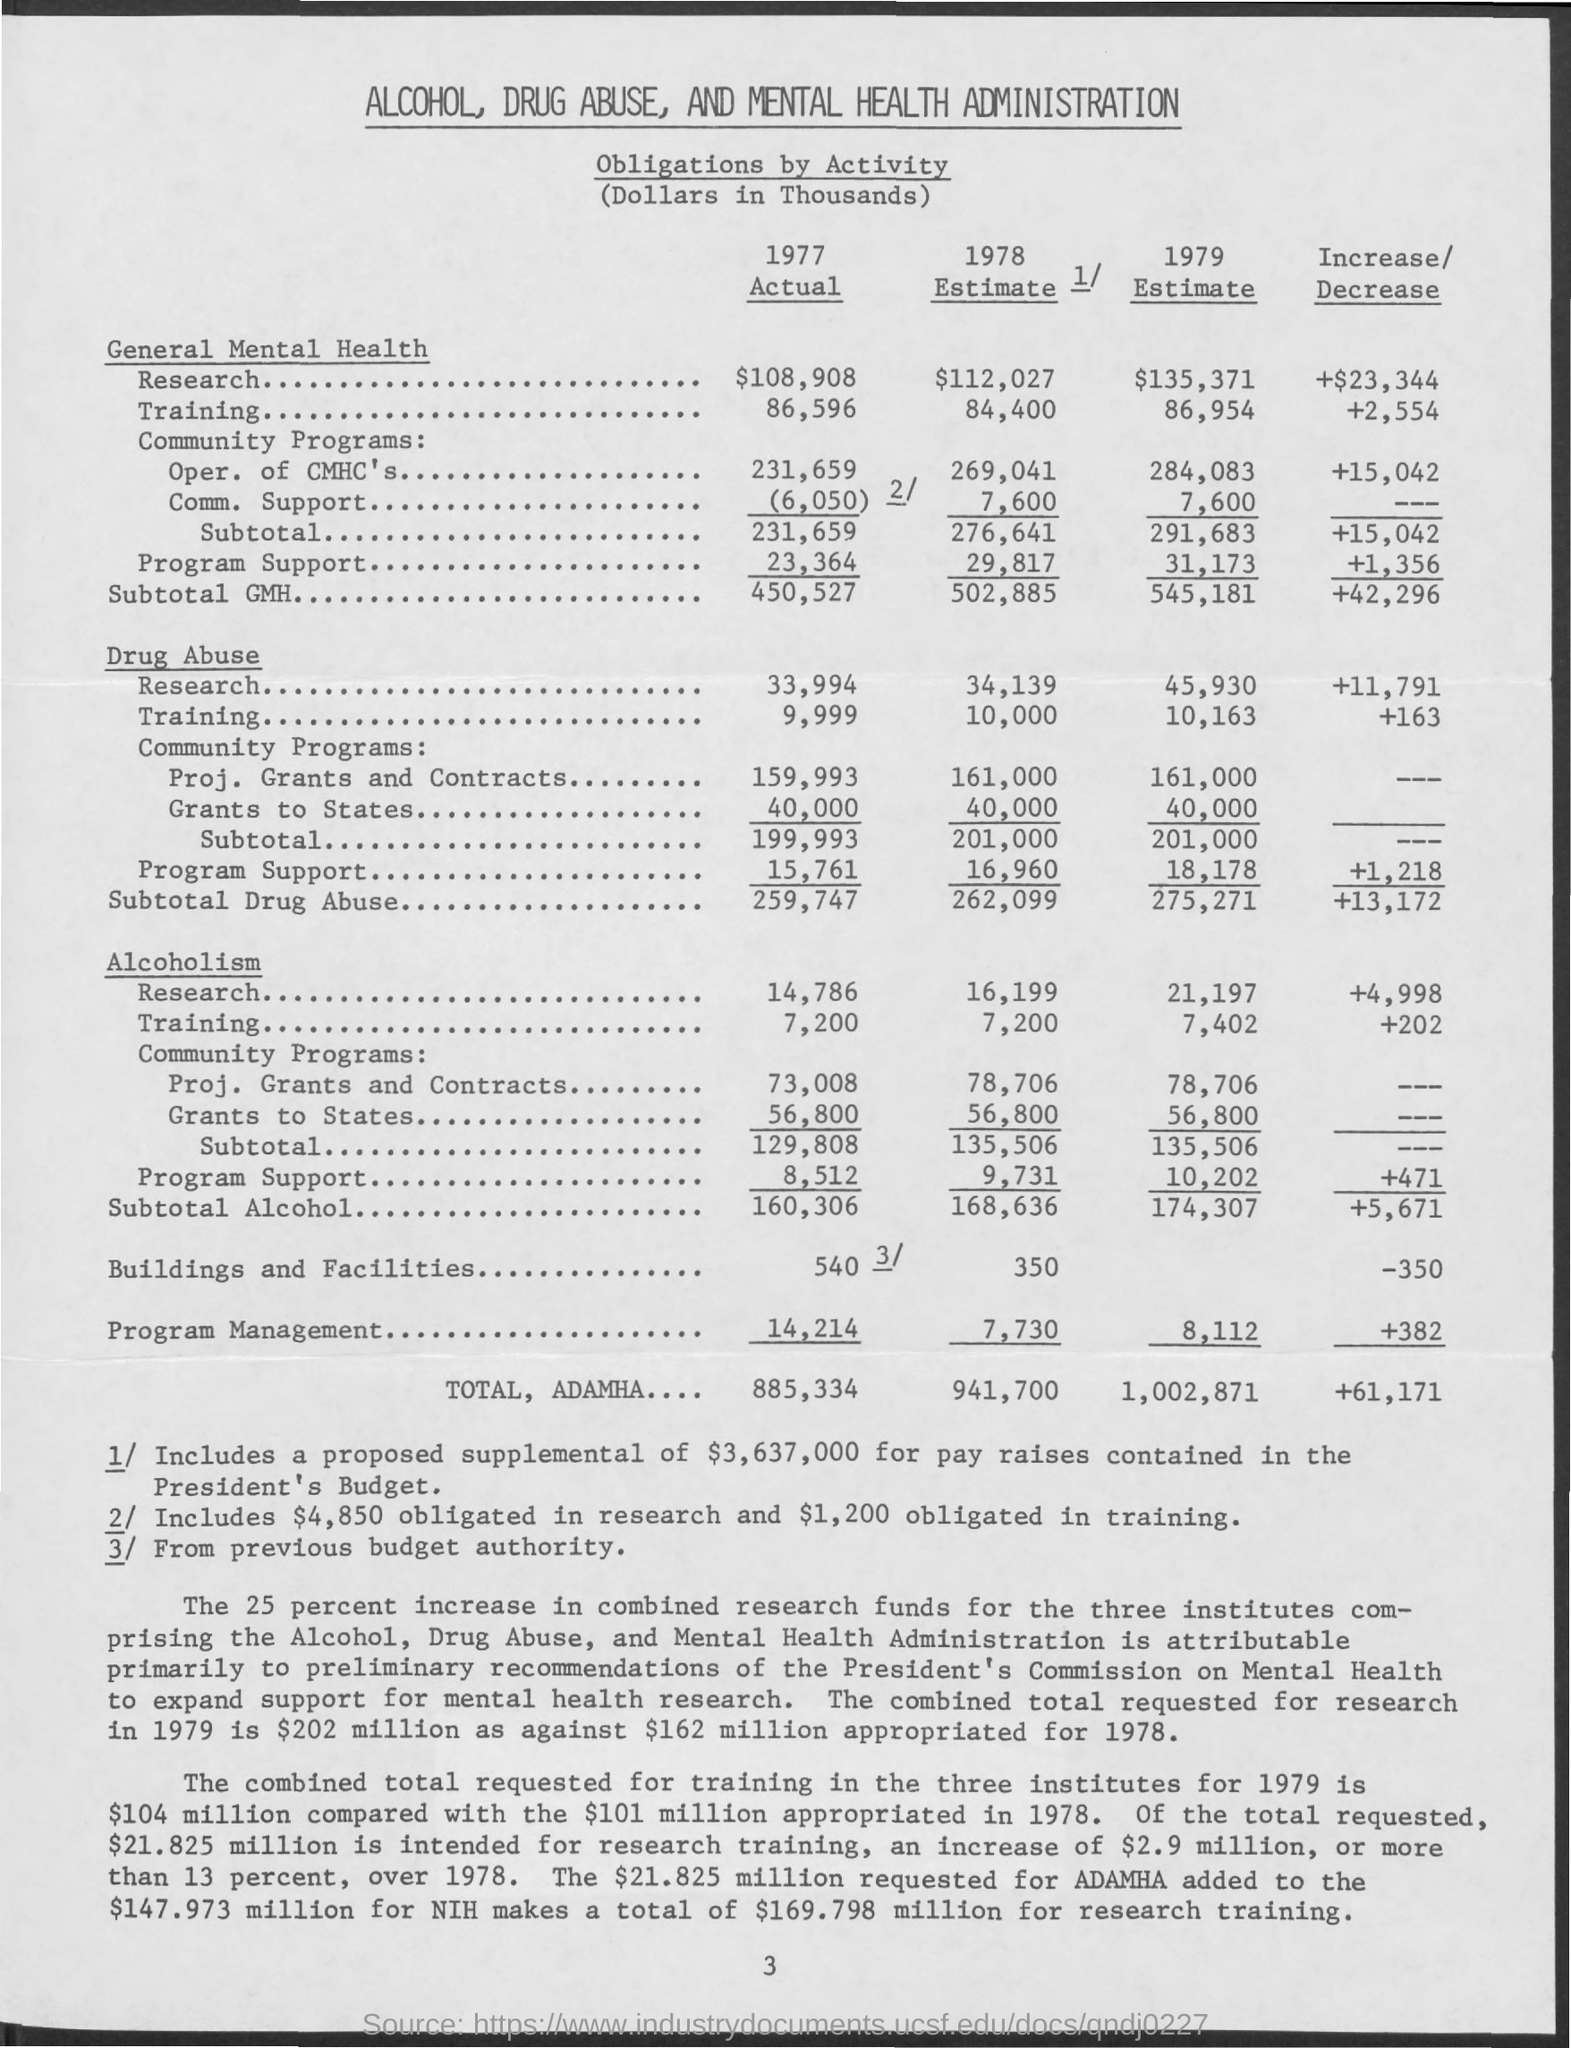What is the general mental health research actual 1977?
Offer a very short reply. 108,908. What is the total , adhma .... of actual 1977
Make the answer very short. 885,334. What is the total , adhma ... of 1979 estimate
Offer a very short reply. 1,002,871. What is the total of increase / decrease ?
Provide a succinct answer. +61,171. 